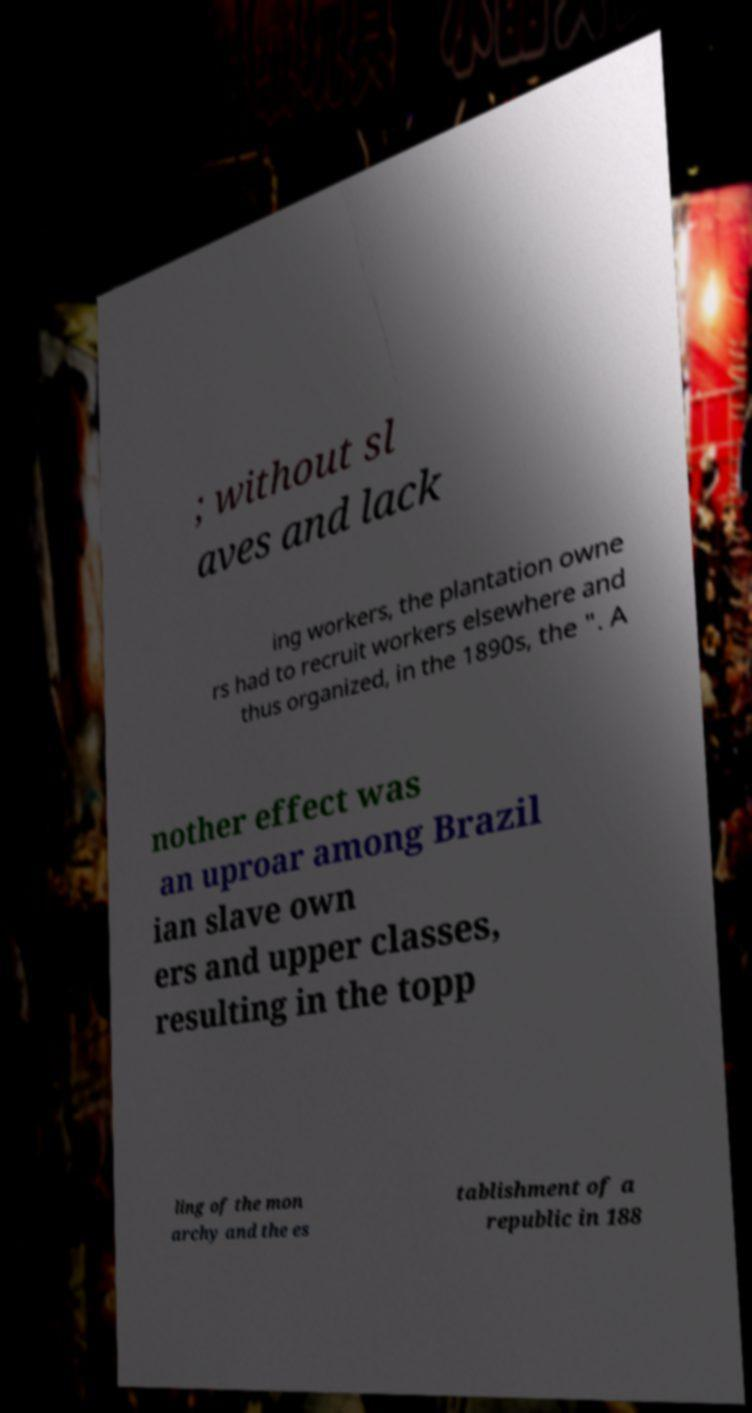Please read and relay the text visible in this image. What does it say? ; without sl aves and lack ing workers, the plantation owne rs had to recruit workers elsewhere and thus organized, in the 1890s, the ". A nother effect was an uproar among Brazil ian slave own ers and upper classes, resulting in the topp ling of the mon archy and the es tablishment of a republic in 188 